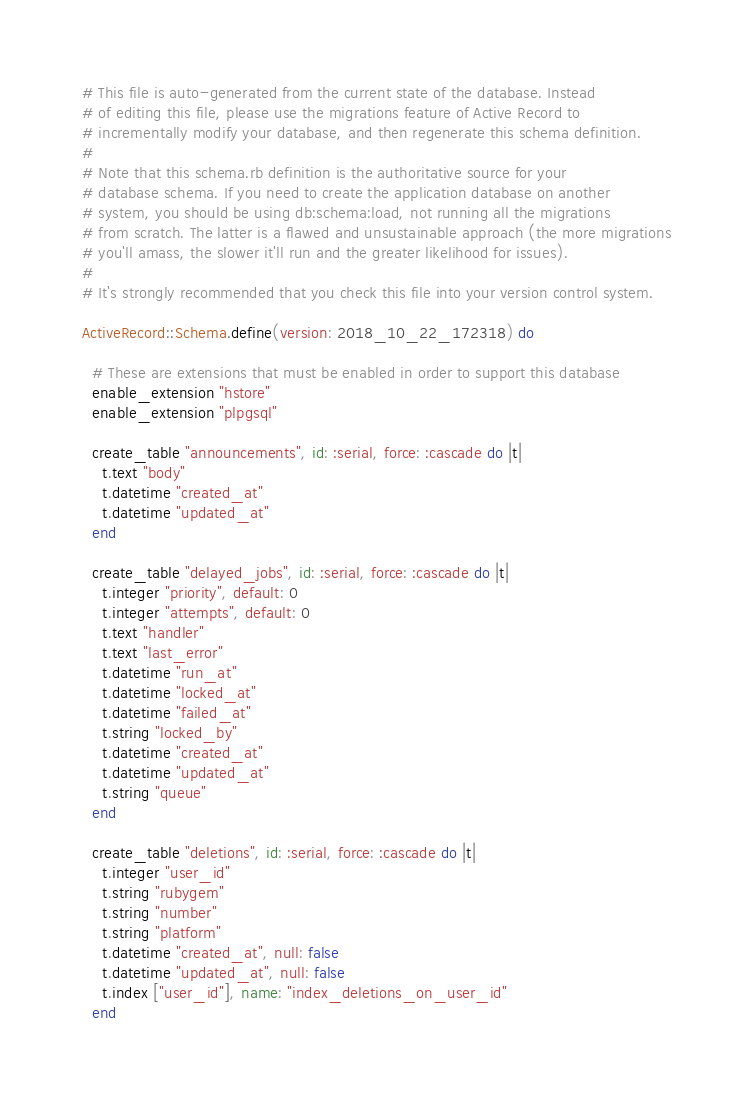<code> <loc_0><loc_0><loc_500><loc_500><_Ruby_># This file is auto-generated from the current state of the database. Instead
# of editing this file, please use the migrations feature of Active Record to
# incrementally modify your database, and then regenerate this schema definition.
#
# Note that this schema.rb definition is the authoritative source for your
# database schema. If you need to create the application database on another
# system, you should be using db:schema:load, not running all the migrations
# from scratch. The latter is a flawed and unsustainable approach (the more migrations
# you'll amass, the slower it'll run and the greater likelihood for issues).
#
# It's strongly recommended that you check this file into your version control system.

ActiveRecord::Schema.define(version: 2018_10_22_172318) do

  # These are extensions that must be enabled in order to support this database
  enable_extension "hstore"
  enable_extension "plpgsql"

  create_table "announcements", id: :serial, force: :cascade do |t|
    t.text "body"
    t.datetime "created_at"
    t.datetime "updated_at"
  end

  create_table "delayed_jobs", id: :serial, force: :cascade do |t|
    t.integer "priority", default: 0
    t.integer "attempts", default: 0
    t.text "handler"
    t.text "last_error"
    t.datetime "run_at"
    t.datetime "locked_at"
    t.datetime "failed_at"
    t.string "locked_by"
    t.datetime "created_at"
    t.datetime "updated_at"
    t.string "queue"
  end

  create_table "deletions", id: :serial, force: :cascade do |t|
    t.integer "user_id"
    t.string "rubygem"
    t.string "number"
    t.string "platform"
    t.datetime "created_at", null: false
    t.datetime "updated_at", null: false
    t.index ["user_id"], name: "index_deletions_on_user_id"
  end
</code> 